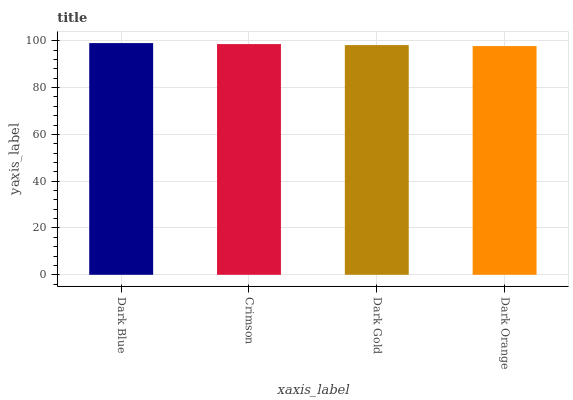Is Dark Orange the minimum?
Answer yes or no. Yes. Is Dark Blue the maximum?
Answer yes or no. Yes. Is Crimson the minimum?
Answer yes or no. No. Is Crimson the maximum?
Answer yes or no. No. Is Dark Blue greater than Crimson?
Answer yes or no. Yes. Is Crimson less than Dark Blue?
Answer yes or no. Yes. Is Crimson greater than Dark Blue?
Answer yes or no. No. Is Dark Blue less than Crimson?
Answer yes or no. No. Is Crimson the high median?
Answer yes or no. Yes. Is Dark Gold the low median?
Answer yes or no. Yes. Is Dark Gold the high median?
Answer yes or no. No. Is Dark Blue the low median?
Answer yes or no. No. 